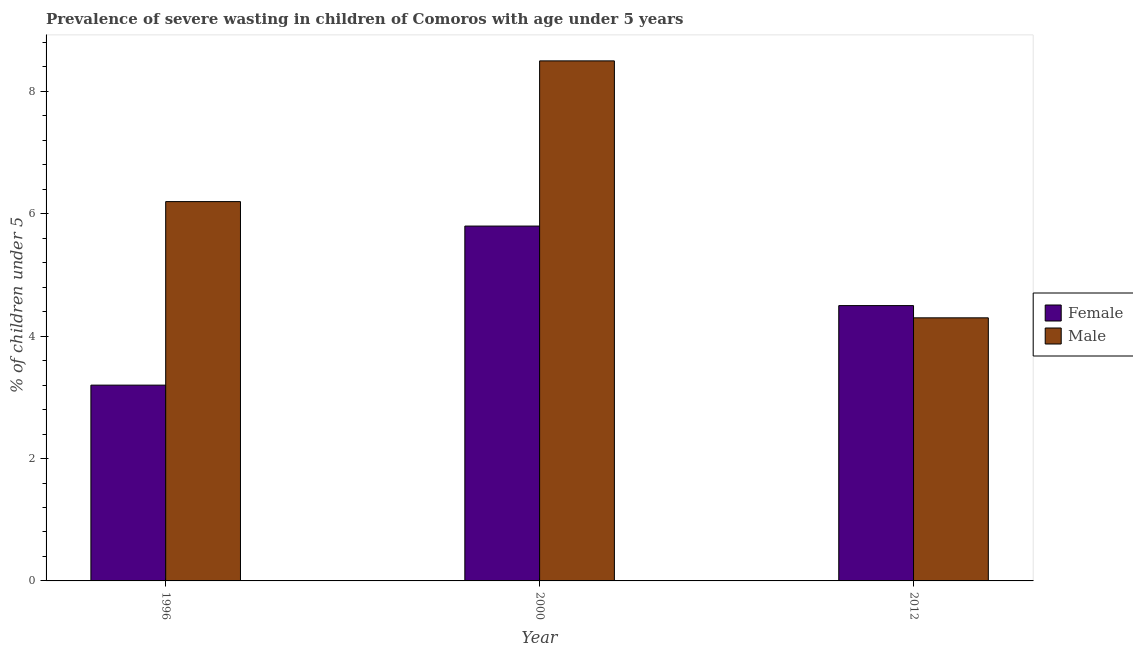How many different coloured bars are there?
Your answer should be very brief. 2. Are the number of bars on each tick of the X-axis equal?
Keep it short and to the point. Yes. What is the percentage of undernourished female children in 2000?
Offer a very short reply. 5.8. Across all years, what is the maximum percentage of undernourished female children?
Your response must be concise. 5.8. Across all years, what is the minimum percentage of undernourished male children?
Provide a succinct answer. 4.3. In which year was the percentage of undernourished male children minimum?
Your response must be concise. 2012. What is the total percentage of undernourished male children in the graph?
Provide a short and direct response. 19. What is the difference between the percentage of undernourished female children in 2000 and that in 2012?
Your answer should be very brief. 1.3. What is the difference between the percentage of undernourished male children in 2012 and the percentage of undernourished female children in 2000?
Your response must be concise. -4.2. What is the average percentage of undernourished female children per year?
Your answer should be very brief. 4.5. What is the ratio of the percentage of undernourished male children in 2000 to that in 2012?
Provide a succinct answer. 1.98. What is the difference between the highest and the second highest percentage of undernourished female children?
Your answer should be compact. 1.3. What is the difference between the highest and the lowest percentage of undernourished male children?
Ensure brevity in your answer.  4.2. In how many years, is the percentage of undernourished male children greater than the average percentage of undernourished male children taken over all years?
Give a very brief answer. 1. What does the 2nd bar from the left in 1996 represents?
Your answer should be very brief. Male. What does the 1st bar from the right in 1996 represents?
Provide a succinct answer. Male. How many bars are there?
Keep it short and to the point. 6. What is the difference between two consecutive major ticks on the Y-axis?
Offer a very short reply. 2. Are the values on the major ticks of Y-axis written in scientific E-notation?
Make the answer very short. No. Does the graph contain any zero values?
Keep it short and to the point. No. How many legend labels are there?
Offer a very short reply. 2. What is the title of the graph?
Your response must be concise. Prevalence of severe wasting in children of Comoros with age under 5 years. What is the label or title of the Y-axis?
Your answer should be compact.  % of children under 5. What is the  % of children under 5 of Female in 1996?
Provide a succinct answer. 3.2. What is the  % of children under 5 in Male in 1996?
Give a very brief answer. 6.2. What is the  % of children under 5 in Female in 2000?
Your response must be concise. 5.8. What is the  % of children under 5 of Male in 2000?
Provide a short and direct response. 8.5. What is the  % of children under 5 in Female in 2012?
Make the answer very short. 4.5. What is the  % of children under 5 of Male in 2012?
Offer a very short reply. 4.3. Across all years, what is the maximum  % of children under 5 of Female?
Your answer should be very brief. 5.8. Across all years, what is the minimum  % of children under 5 of Female?
Offer a terse response. 3.2. Across all years, what is the minimum  % of children under 5 in Male?
Give a very brief answer. 4.3. What is the total  % of children under 5 in Male in the graph?
Your answer should be very brief. 19. What is the difference between the  % of children under 5 in Female in 1996 and that in 2000?
Offer a very short reply. -2.6. What is the difference between the  % of children under 5 in Male in 1996 and that in 2000?
Provide a succinct answer. -2.3. What is the difference between the  % of children under 5 in Male in 1996 and that in 2012?
Make the answer very short. 1.9. What is the difference between the  % of children under 5 of Female in 2000 and that in 2012?
Your answer should be compact. 1.3. What is the difference between the  % of children under 5 of Female in 1996 and the  % of children under 5 of Male in 2012?
Keep it short and to the point. -1.1. What is the difference between the  % of children under 5 of Female in 2000 and the  % of children under 5 of Male in 2012?
Make the answer very short. 1.5. What is the average  % of children under 5 of Female per year?
Provide a succinct answer. 4.5. What is the average  % of children under 5 of Male per year?
Provide a short and direct response. 6.33. In the year 1996, what is the difference between the  % of children under 5 of Female and  % of children under 5 of Male?
Give a very brief answer. -3. What is the ratio of the  % of children under 5 of Female in 1996 to that in 2000?
Offer a very short reply. 0.55. What is the ratio of the  % of children under 5 of Male in 1996 to that in 2000?
Give a very brief answer. 0.73. What is the ratio of the  % of children under 5 in Female in 1996 to that in 2012?
Offer a terse response. 0.71. What is the ratio of the  % of children under 5 in Male in 1996 to that in 2012?
Your response must be concise. 1.44. What is the ratio of the  % of children under 5 of Female in 2000 to that in 2012?
Provide a short and direct response. 1.29. What is the ratio of the  % of children under 5 in Male in 2000 to that in 2012?
Make the answer very short. 1.98. What is the difference between the highest and the second highest  % of children under 5 in Male?
Ensure brevity in your answer.  2.3. What is the difference between the highest and the lowest  % of children under 5 in Female?
Your answer should be compact. 2.6. 